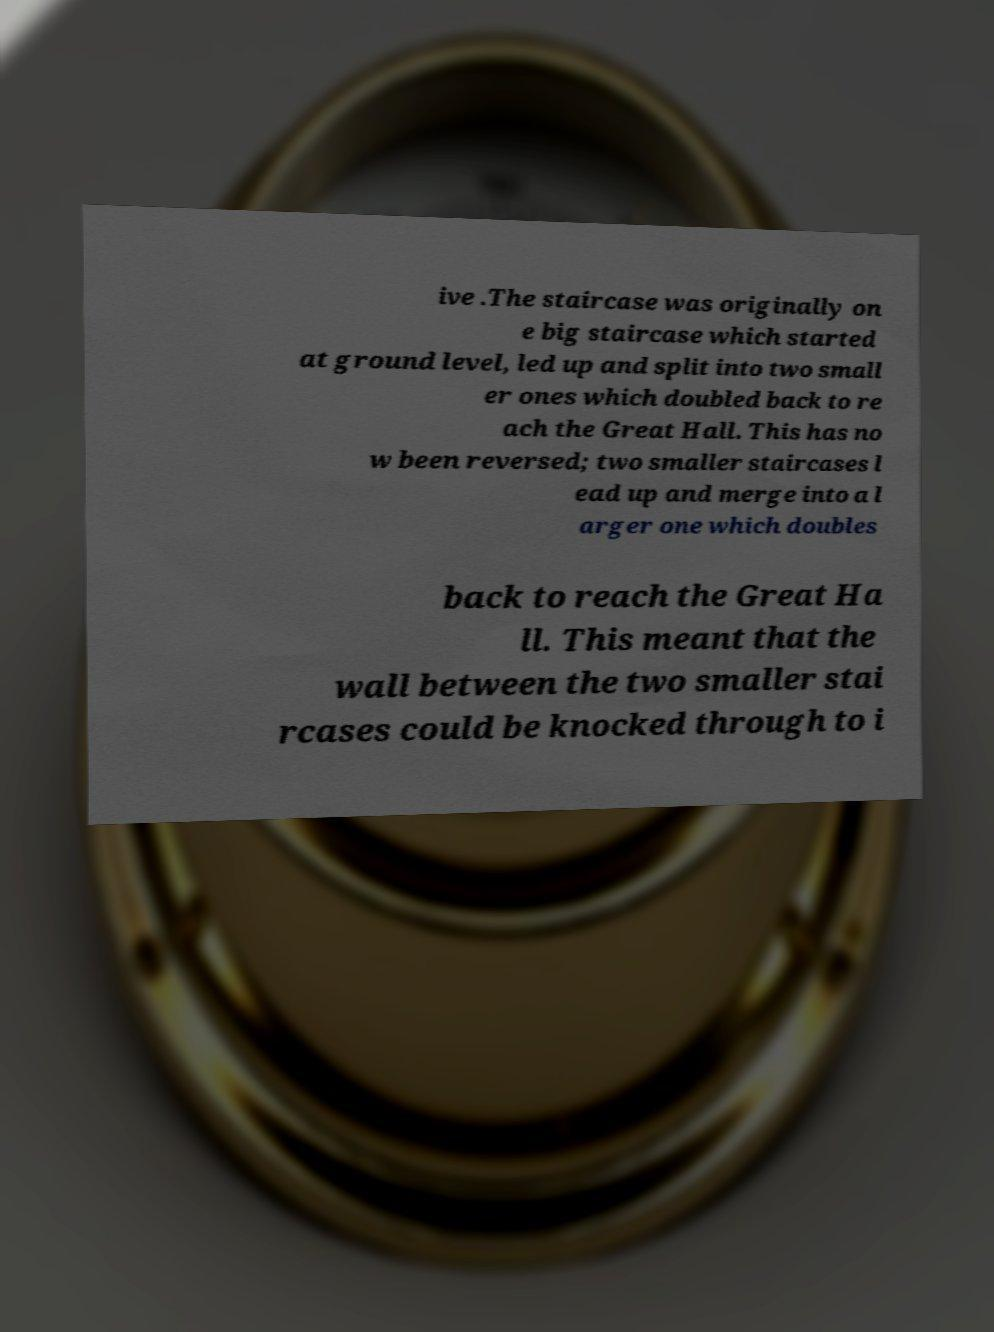Please read and relay the text visible in this image. What does it say? ive .The staircase was originally on e big staircase which started at ground level, led up and split into two small er ones which doubled back to re ach the Great Hall. This has no w been reversed; two smaller staircases l ead up and merge into a l arger one which doubles back to reach the Great Ha ll. This meant that the wall between the two smaller stai rcases could be knocked through to i 